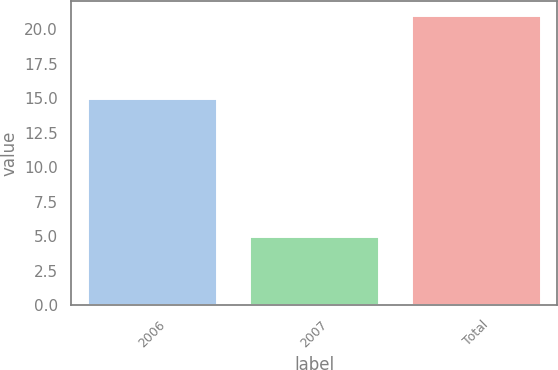Convert chart to OTSL. <chart><loc_0><loc_0><loc_500><loc_500><bar_chart><fcel>2006<fcel>2007<fcel>Total<nl><fcel>15<fcel>5<fcel>21<nl></chart> 